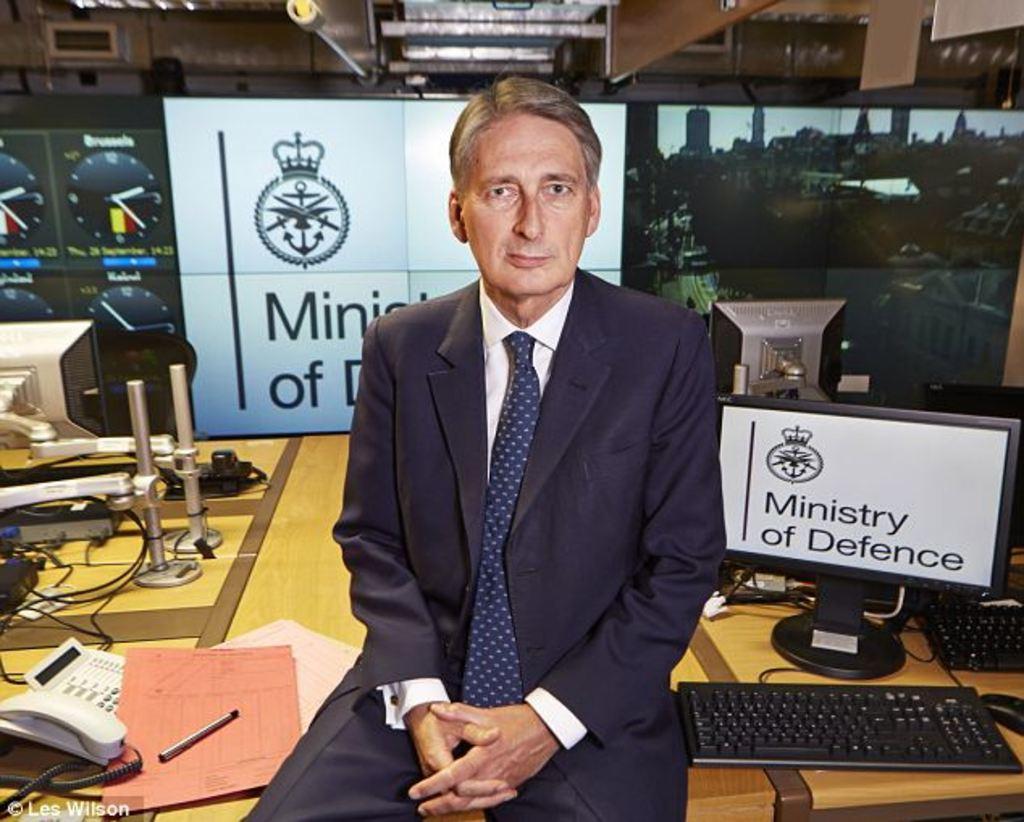Could you give a brief overview of what you see in this image? In this image, we can see a person wearing clothes and sitting on the table. This table contains monitor, keyboards, stands, telephones, file and pen. There is a screen in the middle of the image. There are clocks on the left side of the image. 